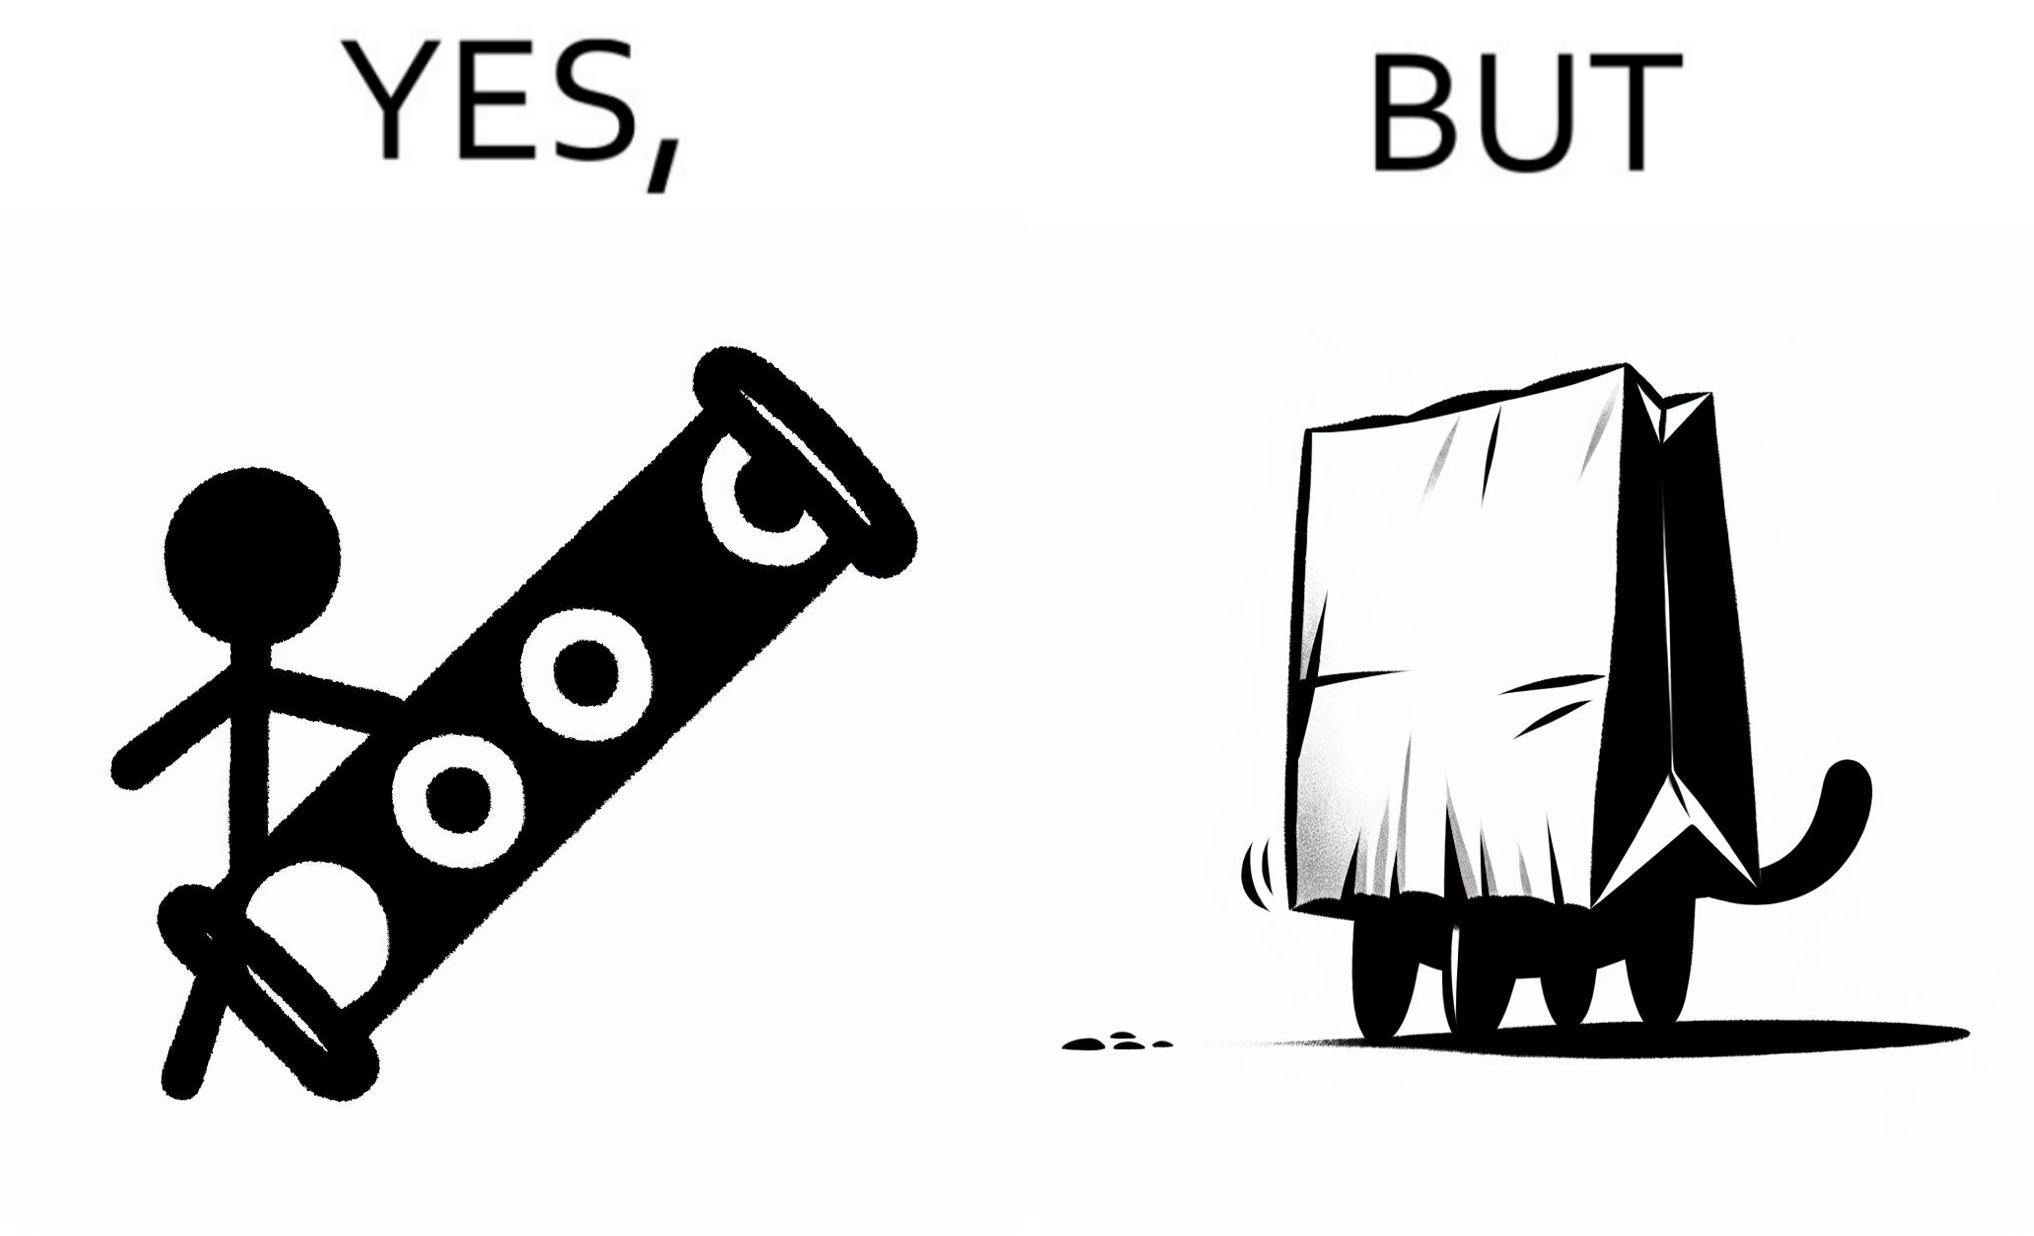Describe the content of this image. The image is funny, because even when there is a dedicated thing for the animal to play with it still is hiding itself in the paper bag 